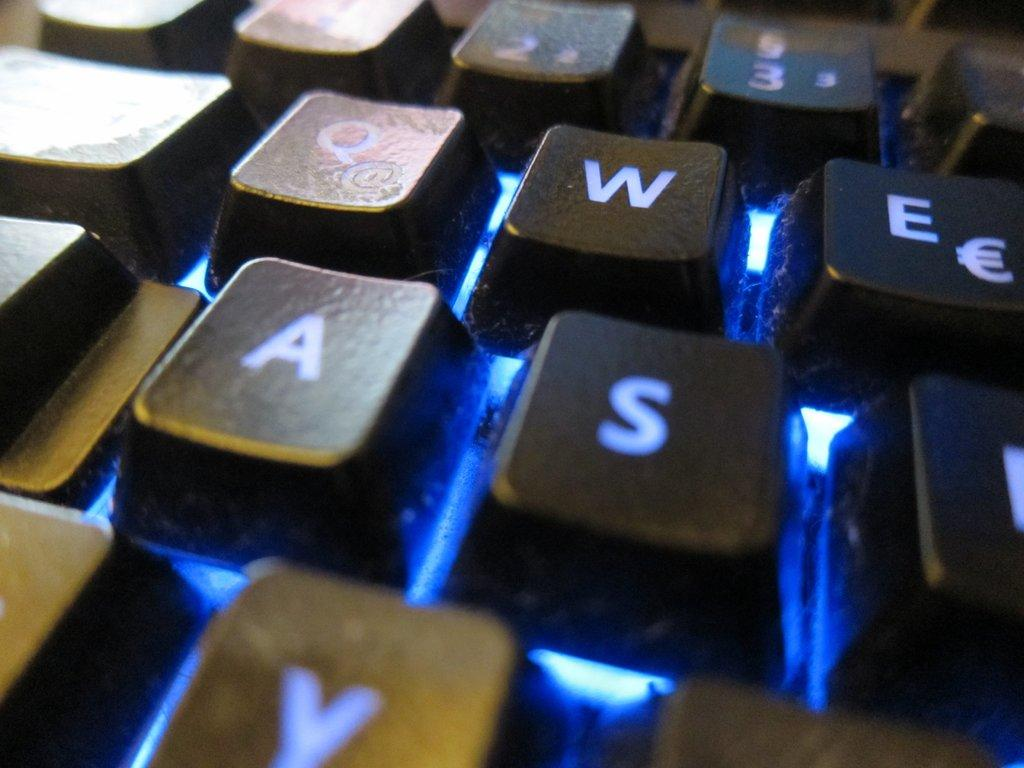<image>
Summarize the visual content of the image. The light from under a keyboard shines blue with particular focus on the letters Q, W, A, and S. 